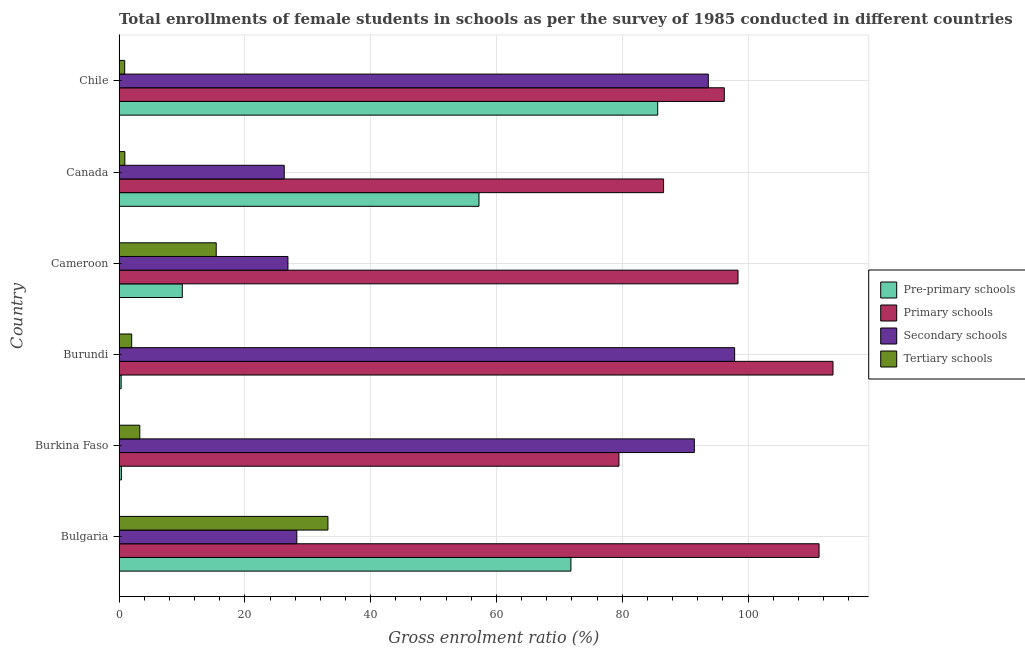Are the number of bars on each tick of the Y-axis equal?
Offer a terse response. Yes. How many bars are there on the 2nd tick from the top?
Keep it short and to the point. 4. How many bars are there on the 2nd tick from the bottom?
Your answer should be compact. 4. What is the label of the 5th group of bars from the top?
Give a very brief answer. Burkina Faso. What is the gross enrolment ratio(female) in secondary schools in Burundi?
Offer a terse response. 97.88. Across all countries, what is the maximum gross enrolment ratio(female) in pre-primary schools?
Give a very brief answer. 85.64. Across all countries, what is the minimum gross enrolment ratio(female) in pre-primary schools?
Ensure brevity in your answer.  0.33. In which country was the gross enrolment ratio(female) in secondary schools maximum?
Give a very brief answer. Burundi. In which country was the gross enrolment ratio(female) in pre-primary schools minimum?
Your answer should be very brief. Burundi. What is the total gross enrolment ratio(female) in tertiary schools in the graph?
Provide a succinct answer. 55.78. What is the difference between the gross enrolment ratio(female) in primary schools in Bulgaria and that in Chile?
Provide a short and direct response. 15.07. What is the difference between the gross enrolment ratio(female) in tertiary schools in Bulgaria and the gross enrolment ratio(female) in secondary schools in Cameroon?
Offer a terse response. 6.36. What is the average gross enrolment ratio(female) in tertiary schools per country?
Give a very brief answer. 9.3. What is the difference between the gross enrolment ratio(female) in secondary schools and gross enrolment ratio(female) in primary schools in Cameroon?
Your response must be concise. -71.56. In how many countries, is the gross enrolment ratio(female) in secondary schools greater than 68 %?
Provide a succinct answer. 3. What is the ratio of the gross enrolment ratio(female) in primary schools in Bulgaria to that in Chile?
Your response must be concise. 1.16. What is the difference between the highest and the second highest gross enrolment ratio(female) in pre-primary schools?
Ensure brevity in your answer.  13.79. What is the difference between the highest and the lowest gross enrolment ratio(female) in pre-primary schools?
Make the answer very short. 85.31. In how many countries, is the gross enrolment ratio(female) in primary schools greater than the average gross enrolment ratio(female) in primary schools taken over all countries?
Your answer should be compact. 3. Is the sum of the gross enrolment ratio(female) in pre-primary schools in Burkina Faso and Canada greater than the maximum gross enrolment ratio(female) in primary schools across all countries?
Provide a succinct answer. No. What does the 4th bar from the top in Cameroon represents?
Give a very brief answer. Pre-primary schools. What does the 3rd bar from the bottom in Cameroon represents?
Offer a very short reply. Secondary schools. Are the values on the major ticks of X-axis written in scientific E-notation?
Provide a short and direct response. No. Does the graph contain any zero values?
Your response must be concise. No. Does the graph contain grids?
Give a very brief answer. Yes. Where does the legend appear in the graph?
Give a very brief answer. Center right. What is the title of the graph?
Your answer should be very brief. Total enrollments of female students in schools as per the survey of 1985 conducted in different countries. What is the label or title of the X-axis?
Ensure brevity in your answer.  Gross enrolment ratio (%). What is the label or title of the Y-axis?
Your response must be concise. Country. What is the Gross enrolment ratio (%) of Pre-primary schools in Bulgaria?
Make the answer very short. 71.84. What is the Gross enrolment ratio (%) in Primary schools in Bulgaria?
Keep it short and to the point. 111.3. What is the Gross enrolment ratio (%) of Secondary schools in Bulgaria?
Provide a succinct answer. 28.26. What is the Gross enrolment ratio (%) in Tertiary schools in Bulgaria?
Offer a terse response. 33.21. What is the Gross enrolment ratio (%) in Pre-primary schools in Burkina Faso?
Provide a succinct answer. 0.38. What is the Gross enrolment ratio (%) in Primary schools in Burkina Faso?
Ensure brevity in your answer.  79.48. What is the Gross enrolment ratio (%) in Secondary schools in Burkina Faso?
Keep it short and to the point. 91.47. What is the Gross enrolment ratio (%) of Tertiary schools in Burkina Faso?
Your answer should be compact. 3.3. What is the Gross enrolment ratio (%) in Pre-primary schools in Burundi?
Give a very brief answer. 0.33. What is the Gross enrolment ratio (%) of Primary schools in Burundi?
Provide a succinct answer. 113.51. What is the Gross enrolment ratio (%) in Secondary schools in Burundi?
Your answer should be very brief. 97.88. What is the Gross enrolment ratio (%) of Tertiary schools in Burundi?
Your answer should be compact. 2.01. What is the Gross enrolment ratio (%) of Pre-primary schools in Cameroon?
Ensure brevity in your answer.  10.06. What is the Gross enrolment ratio (%) in Primary schools in Cameroon?
Offer a terse response. 98.41. What is the Gross enrolment ratio (%) of Secondary schools in Cameroon?
Ensure brevity in your answer.  26.85. What is the Gross enrolment ratio (%) in Tertiary schools in Cameroon?
Offer a very short reply. 15.45. What is the Gross enrolment ratio (%) of Pre-primary schools in Canada?
Make the answer very short. 57.23. What is the Gross enrolment ratio (%) of Primary schools in Canada?
Your answer should be very brief. 86.58. What is the Gross enrolment ratio (%) of Secondary schools in Canada?
Offer a very short reply. 26.26. What is the Gross enrolment ratio (%) of Tertiary schools in Canada?
Give a very brief answer. 0.92. What is the Gross enrolment ratio (%) of Pre-primary schools in Chile?
Your answer should be very brief. 85.64. What is the Gross enrolment ratio (%) in Primary schools in Chile?
Your answer should be compact. 96.23. What is the Gross enrolment ratio (%) of Secondary schools in Chile?
Your answer should be compact. 93.69. What is the Gross enrolment ratio (%) in Tertiary schools in Chile?
Your answer should be very brief. 0.9. Across all countries, what is the maximum Gross enrolment ratio (%) in Pre-primary schools?
Offer a terse response. 85.64. Across all countries, what is the maximum Gross enrolment ratio (%) in Primary schools?
Provide a succinct answer. 113.51. Across all countries, what is the maximum Gross enrolment ratio (%) of Secondary schools?
Keep it short and to the point. 97.88. Across all countries, what is the maximum Gross enrolment ratio (%) of Tertiary schools?
Keep it short and to the point. 33.21. Across all countries, what is the minimum Gross enrolment ratio (%) in Pre-primary schools?
Provide a short and direct response. 0.33. Across all countries, what is the minimum Gross enrolment ratio (%) of Primary schools?
Your answer should be compact. 79.48. Across all countries, what is the minimum Gross enrolment ratio (%) in Secondary schools?
Offer a terse response. 26.26. Across all countries, what is the minimum Gross enrolment ratio (%) of Tertiary schools?
Your response must be concise. 0.9. What is the total Gross enrolment ratio (%) in Pre-primary schools in the graph?
Your response must be concise. 225.48. What is the total Gross enrolment ratio (%) of Primary schools in the graph?
Keep it short and to the point. 585.52. What is the total Gross enrolment ratio (%) in Secondary schools in the graph?
Offer a terse response. 364.42. What is the total Gross enrolment ratio (%) in Tertiary schools in the graph?
Provide a succinct answer. 55.78. What is the difference between the Gross enrolment ratio (%) of Pre-primary schools in Bulgaria and that in Burkina Faso?
Provide a short and direct response. 71.47. What is the difference between the Gross enrolment ratio (%) in Primary schools in Bulgaria and that in Burkina Faso?
Ensure brevity in your answer.  31.82. What is the difference between the Gross enrolment ratio (%) of Secondary schools in Bulgaria and that in Burkina Faso?
Provide a short and direct response. -63.21. What is the difference between the Gross enrolment ratio (%) of Tertiary schools in Bulgaria and that in Burkina Faso?
Provide a succinct answer. 29.91. What is the difference between the Gross enrolment ratio (%) in Pre-primary schools in Bulgaria and that in Burundi?
Your answer should be very brief. 71.51. What is the difference between the Gross enrolment ratio (%) of Primary schools in Bulgaria and that in Burundi?
Your answer should be very brief. -2.22. What is the difference between the Gross enrolment ratio (%) of Secondary schools in Bulgaria and that in Burundi?
Keep it short and to the point. -69.61. What is the difference between the Gross enrolment ratio (%) in Tertiary schools in Bulgaria and that in Burundi?
Ensure brevity in your answer.  31.2. What is the difference between the Gross enrolment ratio (%) in Pre-primary schools in Bulgaria and that in Cameroon?
Make the answer very short. 61.79. What is the difference between the Gross enrolment ratio (%) in Primary schools in Bulgaria and that in Cameroon?
Offer a very short reply. 12.89. What is the difference between the Gross enrolment ratio (%) in Secondary schools in Bulgaria and that in Cameroon?
Make the answer very short. 1.41. What is the difference between the Gross enrolment ratio (%) of Tertiary schools in Bulgaria and that in Cameroon?
Give a very brief answer. 17.76. What is the difference between the Gross enrolment ratio (%) in Pre-primary schools in Bulgaria and that in Canada?
Your response must be concise. 14.62. What is the difference between the Gross enrolment ratio (%) of Primary schools in Bulgaria and that in Canada?
Make the answer very short. 24.72. What is the difference between the Gross enrolment ratio (%) in Secondary schools in Bulgaria and that in Canada?
Offer a terse response. 2. What is the difference between the Gross enrolment ratio (%) of Tertiary schools in Bulgaria and that in Canada?
Provide a succinct answer. 32.29. What is the difference between the Gross enrolment ratio (%) of Pre-primary schools in Bulgaria and that in Chile?
Ensure brevity in your answer.  -13.79. What is the difference between the Gross enrolment ratio (%) in Primary schools in Bulgaria and that in Chile?
Provide a succinct answer. 15.07. What is the difference between the Gross enrolment ratio (%) in Secondary schools in Bulgaria and that in Chile?
Offer a terse response. -65.43. What is the difference between the Gross enrolment ratio (%) of Tertiary schools in Bulgaria and that in Chile?
Your answer should be very brief. 32.31. What is the difference between the Gross enrolment ratio (%) of Pre-primary schools in Burkina Faso and that in Burundi?
Your answer should be very brief. 0.04. What is the difference between the Gross enrolment ratio (%) in Primary schools in Burkina Faso and that in Burundi?
Keep it short and to the point. -34.03. What is the difference between the Gross enrolment ratio (%) of Secondary schools in Burkina Faso and that in Burundi?
Keep it short and to the point. -6.41. What is the difference between the Gross enrolment ratio (%) of Tertiary schools in Burkina Faso and that in Burundi?
Ensure brevity in your answer.  1.29. What is the difference between the Gross enrolment ratio (%) of Pre-primary schools in Burkina Faso and that in Cameroon?
Offer a terse response. -9.68. What is the difference between the Gross enrolment ratio (%) of Primary schools in Burkina Faso and that in Cameroon?
Make the answer very short. -18.93. What is the difference between the Gross enrolment ratio (%) of Secondary schools in Burkina Faso and that in Cameroon?
Provide a short and direct response. 64.62. What is the difference between the Gross enrolment ratio (%) in Tertiary schools in Burkina Faso and that in Cameroon?
Keep it short and to the point. -12.15. What is the difference between the Gross enrolment ratio (%) in Pre-primary schools in Burkina Faso and that in Canada?
Make the answer very short. -56.85. What is the difference between the Gross enrolment ratio (%) in Primary schools in Burkina Faso and that in Canada?
Provide a succinct answer. -7.09. What is the difference between the Gross enrolment ratio (%) in Secondary schools in Burkina Faso and that in Canada?
Your answer should be compact. 65.21. What is the difference between the Gross enrolment ratio (%) in Tertiary schools in Burkina Faso and that in Canada?
Keep it short and to the point. 2.38. What is the difference between the Gross enrolment ratio (%) of Pre-primary schools in Burkina Faso and that in Chile?
Keep it short and to the point. -85.26. What is the difference between the Gross enrolment ratio (%) of Primary schools in Burkina Faso and that in Chile?
Your answer should be very brief. -16.75. What is the difference between the Gross enrolment ratio (%) of Secondary schools in Burkina Faso and that in Chile?
Your answer should be very brief. -2.22. What is the difference between the Gross enrolment ratio (%) of Tertiary schools in Burkina Faso and that in Chile?
Your answer should be compact. 2.4. What is the difference between the Gross enrolment ratio (%) in Pre-primary schools in Burundi and that in Cameroon?
Provide a succinct answer. -9.73. What is the difference between the Gross enrolment ratio (%) of Primary schools in Burundi and that in Cameroon?
Make the answer very short. 15.1. What is the difference between the Gross enrolment ratio (%) in Secondary schools in Burundi and that in Cameroon?
Provide a short and direct response. 71.02. What is the difference between the Gross enrolment ratio (%) in Tertiary schools in Burundi and that in Cameroon?
Offer a terse response. -13.44. What is the difference between the Gross enrolment ratio (%) of Pre-primary schools in Burundi and that in Canada?
Offer a very short reply. -56.9. What is the difference between the Gross enrolment ratio (%) of Primary schools in Burundi and that in Canada?
Your answer should be compact. 26.94. What is the difference between the Gross enrolment ratio (%) in Secondary schools in Burundi and that in Canada?
Ensure brevity in your answer.  71.61. What is the difference between the Gross enrolment ratio (%) in Tertiary schools in Burundi and that in Canada?
Offer a very short reply. 1.09. What is the difference between the Gross enrolment ratio (%) of Pre-primary schools in Burundi and that in Chile?
Your response must be concise. -85.31. What is the difference between the Gross enrolment ratio (%) in Primary schools in Burundi and that in Chile?
Provide a succinct answer. 17.28. What is the difference between the Gross enrolment ratio (%) in Secondary schools in Burundi and that in Chile?
Keep it short and to the point. 4.19. What is the difference between the Gross enrolment ratio (%) of Tertiary schools in Burundi and that in Chile?
Your answer should be very brief. 1.11. What is the difference between the Gross enrolment ratio (%) of Pre-primary schools in Cameroon and that in Canada?
Your answer should be very brief. -47.17. What is the difference between the Gross enrolment ratio (%) in Primary schools in Cameroon and that in Canada?
Make the answer very short. 11.84. What is the difference between the Gross enrolment ratio (%) in Secondary schools in Cameroon and that in Canada?
Offer a terse response. 0.59. What is the difference between the Gross enrolment ratio (%) of Tertiary schools in Cameroon and that in Canada?
Give a very brief answer. 14.53. What is the difference between the Gross enrolment ratio (%) in Pre-primary schools in Cameroon and that in Chile?
Offer a very short reply. -75.58. What is the difference between the Gross enrolment ratio (%) of Primary schools in Cameroon and that in Chile?
Your answer should be compact. 2.18. What is the difference between the Gross enrolment ratio (%) of Secondary schools in Cameroon and that in Chile?
Provide a succinct answer. -66.84. What is the difference between the Gross enrolment ratio (%) of Tertiary schools in Cameroon and that in Chile?
Ensure brevity in your answer.  14.55. What is the difference between the Gross enrolment ratio (%) in Pre-primary schools in Canada and that in Chile?
Offer a very short reply. -28.41. What is the difference between the Gross enrolment ratio (%) of Primary schools in Canada and that in Chile?
Offer a very short reply. -9.65. What is the difference between the Gross enrolment ratio (%) in Secondary schools in Canada and that in Chile?
Offer a terse response. -67.43. What is the difference between the Gross enrolment ratio (%) in Tertiary schools in Canada and that in Chile?
Provide a succinct answer. 0.02. What is the difference between the Gross enrolment ratio (%) in Pre-primary schools in Bulgaria and the Gross enrolment ratio (%) in Primary schools in Burkina Faso?
Give a very brief answer. -7.64. What is the difference between the Gross enrolment ratio (%) of Pre-primary schools in Bulgaria and the Gross enrolment ratio (%) of Secondary schools in Burkina Faso?
Make the answer very short. -19.62. What is the difference between the Gross enrolment ratio (%) of Pre-primary schools in Bulgaria and the Gross enrolment ratio (%) of Tertiary schools in Burkina Faso?
Offer a terse response. 68.55. What is the difference between the Gross enrolment ratio (%) in Primary schools in Bulgaria and the Gross enrolment ratio (%) in Secondary schools in Burkina Faso?
Provide a short and direct response. 19.83. What is the difference between the Gross enrolment ratio (%) of Primary schools in Bulgaria and the Gross enrolment ratio (%) of Tertiary schools in Burkina Faso?
Your answer should be compact. 108. What is the difference between the Gross enrolment ratio (%) of Secondary schools in Bulgaria and the Gross enrolment ratio (%) of Tertiary schools in Burkina Faso?
Provide a succinct answer. 24.97. What is the difference between the Gross enrolment ratio (%) of Pre-primary schools in Bulgaria and the Gross enrolment ratio (%) of Primary schools in Burundi?
Keep it short and to the point. -41.67. What is the difference between the Gross enrolment ratio (%) in Pre-primary schools in Bulgaria and the Gross enrolment ratio (%) in Secondary schools in Burundi?
Make the answer very short. -26.03. What is the difference between the Gross enrolment ratio (%) of Pre-primary schools in Bulgaria and the Gross enrolment ratio (%) of Tertiary schools in Burundi?
Ensure brevity in your answer.  69.83. What is the difference between the Gross enrolment ratio (%) in Primary schools in Bulgaria and the Gross enrolment ratio (%) in Secondary schools in Burundi?
Provide a short and direct response. 13.42. What is the difference between the Gross enrolment ratio (%) of Primary schools in Bulgaria and the Gross enrolment ratio (%) of Tertiary schools in Burundi?
Give a very brief answer. 109.29. What is the difference between the Gross enrolment ratio (%) of Secondary schools in Bulgaria and the Gross enrolment ratio (%) of Tertiary schools in Burundi?
Keep it short and to the point. 26.25. What is the difference between the Gross enrolment ratio (%) of Pre-primary schools in Bulgaria and the Gross enrolment ratio (%) of Primary schools in Cameroon?
Provide a short and direct response. -26.57. What is the difference between the Gross enrolment ratio (%) in Pre-primary schools in Bulgaria and the Gross enrolment ratio (%) in Secondary schools in Cameroon?
Give a very brief answer. 44.99. What is the difference between the Gross enrolment ratio (%) in Pre-primary schools in Bulgaria and the Gross enrolment ratio (%) in Tertiary schools in Cameroon?
Your answer should be compact. 56.4. What is the difference between the Gross enrolment ratio (%) in Primary schools in Bulgaria and the Gross enrolment ratio (%) in Secondary schools in Cameroon?
Offer a terse response. 84.45. What is the difference between the Gross enrolment ratio (%) of Primary schools in Bulgaria and the Gross enrolment ratio (%) of Tertiary schools in Cameroon?
Your response must be concise. 95.85. What is the difference between the Gross enrolment ratio (%) of Secondary schools in Bulgaria and the Gross enrolment ratio (%) of Tertiary schools in Cameroon?
Provide a short and direct response. 12.82. What is the difference between the Gross enrolment ratio (%) of Pre-primary schools in Bulgaria and the Gross enrolment ratio (%) of Primary schools in Canada?
Keep it short and to the point. -14.73. What is the difference between the Gross enrolment ratio (%) in Pre-primary schools in Bulgaria and the Gross enrolment ratio (%) in Secondary schools in Canada?
Your answer should be compact. 45.58. What is the difference between the Gross enrolment ratio (%) of Pre-primary schools in Bulgaria and the Gross enrolment ratio (%) of Tertiary schools in Canada?
Your response must be concise. 70.92. What is the difference between the Gross enrolment ratio (%) in Primary schools in Bulgaria and the Gross enrolment ratio (%) in Secondary schools in Canada?
Your answer should be compact. 85.03. What is the difference between the Gross enrolment ratio (%) of Primary schools in Bulgaria and the Gross enrolment ratio (%) of Tertiary schools in Canada?
Give a very brief answer. 110.38. What is the difference between the Gross enrolment ratio (%) in Secondary schools in Bulgaria and the Gross enrolment ratio (%) in Tertiary schools in Canada?
Make the answer very short. 27.34. What is the difference between the Gross enrolment ratio (%) of Pre-primary schools in Bulgaria and the Gross enrolment ratio (%) of Primary schools in Chile?
Provide a succinct answer. -24.39. What is the difference between the Gross enrolment ratio (%) of Pre-primary schools in Bulgaria and the Gross enrolment ratio (%) of Secondary schools in Chile?
Give a very brief answer. -21.85. What is the difference between the Gross enrolment ratio (%) in Pre-primary schools in Bulgaria and the Gross enrolment ratio (%) in Tertiary schools in Chile?
Provide a short and direct response. 70.95. What is the difference between the Gross enrolment ratio (%) of Primary schools in Bulgaria and the Gross enrolment ratio (%) of Secondary schools in Chile?
Provide a succinct answer. 17.61. What is the difference between the Gross enrolment ratio (%) of Primary schools in Bulgaria and the Gross enrolment ratio (%) of Tertiary schools in Chile?
Your response must be concise. 110.4. What is the difference between the Gross enrolment ratio (%) in Secondary schools in Bulgaria and the Gross enrolment ratio (%) in Tertiary schools in Chile?
Ensure brevity in your answer.  27.37. What is the difference between the Gross enrolment ratio (%) of Pre-primary schools in Burkina Faso and the Gross enrolment ratio (%) of Primary schools in Burundi?
Keep it short and to the point. -113.14. What is the difference between the Gross enrolment ratio (%) of Pre-primary schools in Burkina Faso and the Gross enrolment ratio (%) of Secondary schools in Burundi?
Provide a short and direct response. -97.5. What is the difference between the Gross enrolment ratio (%) in Pre-primary schools in Burkina Faso and the Gross enrolment ratio (%) in Tertiary schools in Burundi?
Ensure brevity in your answer.  -1.63. What is the difference between the Gross enrolment ratio (%) in Primary schools in Burkina Faso and the Gross enrolment ratio (%) in Secondary schools in Burundi?
Provide a short and direct response. -18.39. What is the difference between the Gross enrolment ratio (%) of Primary schools in Burkina Faso and the Gross enrolment ratio (%) of Tertiary schools in Burundi?
Provide a succinct answer. 77.47. What is the difference between the Gross enrolment ratio (%) of Secondary schools in Burkina Faso and the Gross enrolment ratio (%) of Tertiary schools in Burundi?
Provide a short and direct response. 89.46. What is the difference between the Gross enrolment ratio (%) in Pre-primary schools in Burkina Faso and the Gross enrolment ratio (%) in Primary schools in Cameroon?
Provide a short and direct response. -98.04. What is the difference between the Gross enrolment ratio (%) in Pre-primary schools in Burkina Faso and the Gross enrolment ratio (%) in Secondary schools in Cameroon?
Give a very brief answer. -26.48. What is the difference between the Gross enrolment ratio (%) of Pre-primary schools in Burkina Faso and the Gross enrolment ratio (%) of Tertiary schools in Cameroon?
Provide a short and direct response. -15.07. What is the difference between the Gross enrolment ratio (%) of Primary schools in Burkina Faso and the Gross enrolment ratio (%) of Secondary schools in Cameroon?
Give a very brief answer. 52.63. What is the difference between the Gross enrolment ratio (%) of Primary schools in Burkina Faso and the Gross enrolment ratio (%) of Tertiary schools in Cameroon?
Make the answer very short. 64.04. What is the difference between the Gross enrolment ratio (%) of Secondary schools in Burkina Faso and the Gross enrolment ratio (%) of Tertiary schools in Cameroon?
Your answer should be very brief. 76.02. What is the difference between the Gross enrolment ratio (%) in Pre-primary schools in Burkina Faso and the Gross enrolment ratio (%) in Primary schools in Canada?
Your answer should be compact. -86.2. What is the difference between the Gross enrolment ratio (%) in Pre-primary schools in Burkina Faso and the Gross enrolment ratio (%) in Secondary schools in Canada?
Provide a succinct answer. -25.89. What is the difference between the Gross enrolment ratio (%) in Pre-primary schools in Burkina Faso and the Gross enrolment ratio (%) in Tertiary schools in Canada?
Your answer should be very brief. -0.54. What is the difference between the Gross enrolment ratio (%) of Primary schools in Burkina Faso and the Gross enrolment ratio (%) of Secondary schools in Canada?
Provide a short and direct response. 53.22. What is the difference between the Gross enrolment ratio (%) in Primary schools in Burkina Faso and the Gross enrolment ratio (%) in Tertiary schools in Canada?
Offer a terse response. 78.56. What is the difference between the Gross enrolment ratio (%) of Secondary schools in Burkina Faso and the Gross enrolment ratio (%) of Tertiary schools in Canada?
Your response must be concise. 90.55. What is the difference between the Gross enrolment ratio (%) in Pre-primary schools in Burkina Faso and the Gross enrolment ratio (%) in Primary schools in Chile?
Offer a very short reply. -95.85. What is the difference between the Gross enrolment ratio (%) of Pre-primary schools in Burkina Faso and the Gross enrolment ratio (%) of Secondary schools in Chile?
Your answer should be compact. -93.31. What is the difference between the Gross enrolment ratio (%) of Pre-primary schools in Burkina Faso and the Gross enrolment ratio (%) of Tertiary schools in Chile?
Your answer should be compact. -0.52. What is the difference between the Gross enrolment ratio (%) of Primary schools in Burkina Faso and the Gross enrolment ratio (%) of Secondary schools in Chile?
Your answer should be very brief. -14.21. What is the difference between the Gross enrolment ratio (%) of Primary schools in Burkina Faso and the Gross enrolment ratio (%) of Tertiary schools in Chile?
Make the answer very short. 78.59. What is the difference between the Gross enrolment ratio (%) of Secondary schools in Burkina Faso and the Gross enrolment ratio (%) of Tertiary schools in Chile?
Provide a succinct answer. 90.57. What is the difference between the Gross enrolment ratio (%) in Pre-primary schools in Burundi and the Gross enrolment ratio (%) in Primary schools in Cameroon?
Offer a very short reply. -98.08. What is the difference between the Gross enrolment ratio (%) of Pre-primary schools in Burundi and the Gross enrolment ratio (%) of Secondary schools in Cameroon?
Ensure brevity in your answer.  -26.52. What is the difference between the Gross enrolment ratio (%) in Pre-primary schools in Burundi and the Gross enrolment ratio (%) in Tertiary schools in Cameroon?
Offer a very short reply. -15.12. What is the difference between the Gross enrolment ratio (%) in Primary schools in Burundi and the Gross enrolment ratio (%) in Secondary schools in Cameroon?
Provide a succinct answer. 86.66. What is the difference between the Gross enrolment ratio (%) of Primary schools in Burundi and the Gross enrolment ratio (%) of Tertiary schools in Cameroon?
Give a very brief answer. 98.07. What is the difference between the Gross enrolment ratio (%) in Secondary schools in Burundi and the Gross enrolment ratio (%) in Tertiary schools in Cameroon?
Offer a very short reply. 82.43. What is the difference between the Gross enrolment ratio (%) in Pre-primary schools in Burundi and the Gross enrolment ratio (%) in Primary schools in Canada?
Provide a succinct answer. -86.25. What is the difference between the Gross enrolment ratio (%) in Pre-primary schools in Burundi and the Gross enrolment ratio (%) in Secondary schools in Canada?
Give a very brief answer. -25.93. What is the difference between the Gross enrolment ratio (%) of Pre-primary schools in Burundi and the Gross enrolment ratio (%) of Tertiary schools in Canada?
Your answer should be very brief. -0.59. What is the difference between the Gross enrolment ratio (%) of Primary schools in Burundi and the Gross enrolment ratio (%) of Secondary schools in Canada?
Your response must be concise. 87.25. What is the difference between the Gross enrolment ratio (%) in Primary schools in Burundi and the Gross enrolment ratio (%) in Tertiary schools in Canada?
Your response must be concise. 112.59. What is the difference between the Gross enrolment ratio (%) in Secondary schools in Burundi and the Gross enrolment ratio (%) in Tertiary schools in Canada?
Your answer should be very brief. 96.96. What is the difference between the Gross enrolment ratio (%) of Pre-primary schools in Burundi and the Gross enrolment ratio (%) of Primary schools in Chile?
Keep it short and to the point. -95.9. What is the difference between the Gross enrolment ratio (%) in Pre-primary schools in Burundi and the Gross enrolment ratio (%) in Secondary schools in Chile?
Offer a terse response. -93.36. What is the difference between the Gross enrolment ratio (%) of Pre-primary schools in Burundi and the Gross enrolment ratio (%) of Tertiary schools in Chile?
Your response must be concise. -0.57. What is the difference between the Gross enrolment ratio (%) in Primary schools in Burundi and the Gross enrolment ratio (%) in Secondary schools in Chile?
Your response must be concise. 19.82. What is the difference between the Gross enrolment ratio (%) in Primary schools in Burundi and the Gross enrolment ratio (%) in Tertiary schools in Chile?
Offer a terse response. 112.62. What is the difference between the Gross enrolment ratio (%) of Secondary schools in Burundi and the Gross enrolment ratio (%) of Tertiary schools in Chile?
Make the answer very short. 96.98. What is the difference between the Gross enrolment ratio (%) of Pre-primary schools in Cameroon and the Gross enrolment ratio (%) of Primary schools in Canada?
Your answer should be compact. -76.52. What is the difference between the Gross enrolment ratio (%) of Pre-primary schools in Cameroon and the Gross enrolment ratio (%) of Secondary schools in Canada?
Provide a short and direct response. -16.21. What is the difference between the Gross enrolment ratio (%) of Pre-primary schools in Cameroon and the Gross enrolment ratio (%) of Tertiary schools in Canada?
Your response must be concise. 9.14. What is the difference between the Gross enrolment ratio (%) in Primary schools in Cameroon and the Gross enrolment ratio (%) in Secondary schools in Canada?
Ensure brevity in your answer.  72.15. What is the difference between the Gross enrolment ratio (%) in Primary schools in Cameroon and the Gross enrolment ratio (%) in Tertiary schools in Canada?
Offer a very short reply. 97.49. What is the difference between the Gross enrolment ratio (%) in Secondary schools in Cameroon and the Gross enrolment ratio (%) in Tertiary schools in Canada?
Provide a succinct answer. 25.93. What is the difference between the Gross enrolment ratio (%) in Pre-primary schools in Cameroon and the Gross enrolment ratio (%) in Primary schools in Chile?
Give a very brief answer. -86.17. What is the difference between the Gross enrolment ratio (%) in Pre-primary schools in Cameroon and the Gross enrolment ratio (%) in Secondary schools in Chile?
Ensure brevity in your answer.  -83.63. What is the difference between the Gross enrolment ratio (%) in Pre-primary schools in Cameroon and the Gross enrolment ratio (%) in Tertiary schools in Chile?
Ensure brevity in your answer.  9.16. What is the difference between the Gross enrolment ratio (%) in Primary schools in Cameroon and the Gross enrolment ratio (%) in Secondary schools in Chile?
Give a very brief answer. 4.72. What is the difference between the Gross enrolment ratio (%) in Primary schools in Cameroon and the Gross enrolment ratio (%) in Tertiary schools in Chile?
Give a very brief answer. 97.52. What is the difference between the Gross enrolment ratio (%) in Secondary schools in Cameroon and the Gross enrolment ratio (%) in Tertiary schools in Chile?
Offer a very short reply. 25.96. What is the difference between the Gross enrolment ratio (%) of Pre-primary schools in Canada and the Gross enrolment ratio (%) of Primary schools in Chile?
Offer a terse response. -39. What is the difference between the Gross enrolment ratio (%) in Pre-primary schools in Canada and the Gross enrolment ratio (%) in Secondary schools in Chile?
Give a very brief answer. -36.46. What is the difference between the Gross enrolment ratio (%) in Pre-primary schools in Canada and the Gross enrolment ratio (%) in Tertiary schools in Chile?
Offer a terse response. 56.33. What is the difference between the Gross enrolment ratio (%) in Primary schools in Canada and the Gross enrolment ratio (%) in Secondary schools in Chile?
Offer a very short reply. -7.11. What is the difference between the Gross enrolment ratio (%) in Primary schools in Canada and the Gross enrolment ratio (%) in Tertiary schools in Chile?
Keep it short and to the point. 85.68. What is the difference between the Gross enrolment ratio (%) of Secondary schools in Canada and the Gross enrolment ratio (%) of Tertiary schools in Chile?
Provide a succinct answer. 25.37. What is the average Gross enrolment ratio (%) of Pre-primary schools per country?
Ensure brevity in your answer.  37.58. What is the average Gross enrolment ratio (%) of Primary schools per country?
Provide a short and direct response. 97.59. What is the average Gross enrolment ratio (%) of Secondary schools per country?
Make the answer very short. 60.74. What is the average Gross enrolment ratio (%) of Tertiary schools per country?
Your response must be concise. 9.3. What is the difference between the Gross enrolment ratio (%) of Pre-primary schools and Gross enrolment ratio (%) of Primary schools in Bulgaria?
Offer a terse response. -39.45. What is the difference between the Gross enrolment ratio (%) in Pre-primary schools and Gross enrolment ratio (%) in Secondary schools in Bulgaria?
Make the answer very short. 43.58. What is the difference between the Gross enrolment ratio (%) of Pre-primary schools and Gross enrolment ratio (%) of Tertiary schools in Bulgaria?
Provide a succinct answer. 38.63. What is the difference between the Gross enrolment ratio (%) of Primary schools and Gross enrolment ratio (%) of Secondary schools in Bulgaria?
Give a very brief answer. 83.03. What is the difference between the Gross enrolment ratio (%) in Primary schools and Gross enrolment ratio (%) in Tertiary schools in Bulgaria?
Your response must be concise. 78.09. What is the difference between the Gross enrolment ratio (%) of Secondary schools and Gross enrolment ratio (%) of Tertiary schools in Bulgaria?
Offer a terse response. -4.95. What is the difference between the Gross enrolment ratio (%) of Pre-primary schools and Gross enrolment ratio (%) of Primary schools in Burkina Faso?
Provide a succinct answer. -79.11. What is the difference between the Gross enrolment ratio (%) of Pre-primary schools and Gross enrolment ratio (%) of Secondary schools in Burkina Faso?
Provide a short and direct response. -91.09. What is the difference between the Gross enrolment ratio (%) of Pre-primary schools and Gross enrolment ratio (%) of Tertiary schools in Burkina Faso?
Provide a short and direct response. -2.92. What is the difference between the Gross enrolment ratio (%) in Primary schools and Gross enrolment ratio (%) in Secondary schools in Burkina Faso?
Offer a very short reply. -11.99. What is the difference between the Gross enrolment ratio (%) in Primary schools and Gross enrolment ratio (%) in Tertiary schools in Burkina Faso?
Provide a succinct answer. 76.19. What is the difference between the Gross enrolment ratio (%) in Secondary schools and Gross enrolment ratio (%) in Tertiary schools in Burkina Faso?
Offer a very short reply. 88.17. What is the difference between the Gross enrolment ratio (%) of Pre-primary schools and Gross enrolment ratio (%) of Primary schools in Burundi?
Offer a terse response. -113.18. What is the difference between the Gross enrolment ratio (%) of Pre-primary schools and Gross enrolment ratio (%) of Secondary schools in Burundi?
Make the answer very short. -97.54. What is the difference between the Gross enrolment ratio (%) in Pre-primary schools and Gross enrolment ratio (%) in Tertiary schools in Burundi?
Keep it short and to the point. -1.68. What is the difference between the Gross enrolment ratio (%) in Primary schools and Gross enrolment ratio (%) in Secondary schools in Burundi?
Provide a short and direct response. 15.64. What is the difference between the Gross enrolment ratio (%) of Primary schools and Gross enrolment ratio (%) of Tertiary schools in Burundi?
Provide a short and direct response. 111.5. What is the difference between the Gross enrolment ratio (%) of Secondary schools and Gross enrolment ratio (%) of Tertiary schools in Burundi?
Your response must be concise. 95.87. What is the difference between the Gross enrolment ratio (%) in Pre-primary schools and Gross enrolment ratio (%) in Primary schools in Cameroon?
Ensure brevity in your answer.  -88.36. What is the difference between the Gross enrolment ratio (%) of Pre-primary schools and Gross enrolment ratio (%) of Secondary schools in Cameroon?
Ensure brevity in your answer.  -16.8. What is the difference between the Gross enrolment ratio (%) in Pre-primary schools and Gross enrolment ratio (%) in Tertiary schools in Cameroon?
Give a very brief answer. -5.39. What is the difference between the Gross enrolment ratio (%) of Primary schools and Gross enrolment ratio (%) of Secondary schools in Cameroon?
Your answer should be very brief. 71.56. What is the difference between the Gross enrolment ratio (%) of Primary schools and Gross enrolment ratio (%) of Tertiary schools in Cameroon?
Make the answer very short. 82.97. What is the difference between the Gross enrolment ratio (%) of Secondary schools and Gross enrolment ratio (%) of Tertiary schools in Cameroon?
Your answer should be compact. 11.41. What is the difference between the Gross enrolment ratio (%) of Pre-primary schools and Gross enrolment ratio (%) of Primary schools in Canada?
Ensure brevity in your answer.  -29.35. What is the difference between the Gross enrolment ratio (%) of Pre-primary schools and Gross enrolment ratio (%) of Secondary schools in Canada?
Give a very brief answer. 30.96. What is the difference between the Gross enrolment ratio (%) of Pre-primary schools and Gross enrolment ratio (%) of Tertiary schools in Canada?
Ensure brevity in your answer.  56.31. What is the difference between the Gross enrolment ratio (%) in Primary schools and Gross enrolment ratio (%) in Secondary schools in Canada?
Make the answer very short. 60.31. What is the difference between the Gross enrolment ratio (%) of Primary schools and Gross enrolment ratio (%) of Tertiary schools in Canada?
Offer a very short reply. 85.66. What is the difference between the Gross enrolment ratio (%) in Secondary schools and Gross enrolment ratio (%) in Tertiary schools in Canada?
Make the answer very short. 25.34. What is the difference between the Gross enrolment ratio (%) of Pre-primary schools and Gross enrolment ratio (%) of Primary schools in Chile?
Your answer should be compact. -10.59. What is the difference between the Gross enrolment ratio (%) in Pre-primary schools and Gross enrolment ratio (%) in Secondary schools in Chile?
Offer a very short reply. -8.05. What is the difference between the Gross enrolment ratio (%) in Pre-primary schools and Gross enrolment ratio (%) in Tertiary schools in Chile?
Your answer should be compact. 84.74. What is the difference between the Gross enrolment ratio (%) in Primary schools and Gross enrolment ratio (%) in Secondary schools in Chile?
Offer a terse response. 2.54. What is the difference between the Gross enrolment ratio (%) of Primary schools and Gross enrolment ratio (%) of Tertiary schools in Chile?
Provide a succinct answer. 95.33. What is the difference between the Gross enrolment ratio (%) in Secondary schools and Gross enrolment ratio (%) in Tertiary schools in Chile?
Offer a very short reply. 92.79. What is the ratio of the Gross enrolment ratio (%) in Pre-primary schools in Bulgaria to that in Burkina Faso?
Ensure brevity in your answer.  191.33. What is the ratio of the Gross enrolment ratio (%) in Primary schools in Bulgaria to that in Burkina Faso?
Offer a very short reply. 1.4. What is the ratio of the Gross enrolment ratio (%) of Secondary schools in Bulgaria to that in Burkina Faso?
Offer a terse response. 0.31. What is the ratio of the Gross enrolment ratio (%) of Tertiary schools in Bulgaria to that in Burkina Faso?
Provide a short and direct response. 10.07. What is the ratio of the Gross enrolment ratio (%) of Pre-primary schools in Bulgaria to that in Burundi?
Ensure brevity in your answer.  216.61. What is the ratio of the Gross enrolment ratio (%) of Primary schools in Bulgaria to that in Burundi?
Ensure brevity in your answer.  0.98. What is the ratio of the Gross enrolment ratio (%) of Secondary schools in Bulgaria to that in Burundi?
Offer a terse response. 0.29. What is the ratio of the Gross enrolment ratio (%) of Tertiary schools in Bulgaria to that in Burundi?
Provide a succinct answer. 16.52. What is the ratio of the Gross enrolment ratio (%) in Pre-primary schools in Bulgaria to that in Cameroon?
Keep it short and to the point. 7.14. What is the ratio of the Gross enrolment ratio (%) in Primary schools in Bulgaria to that in Cameroon?
Offer a terse response. 1.13. What is the ratio of the Gross enrolment ratio (%) of Secondary schools in Bulgaria to that in Cameroon?
Make the answer very short. 1.05. What is the ratio of the Gross enrolment ratio (%) in Tertiary schools in Bulgaria to that in Cameroon?
Offer a terse response. 2.15. What is the ratio of the Gross enrolment ratio (%) in Pre-primary schools in Bulgaria to that in Canada?
Provide a succinct answer. 1.26. What is the ratio of the Gross enrolment ratio (%) in Primary schools in Bulgaria to that in Canada?
Your answer should be very brief. 1.29. What is the ratio of the Gross enrolment ratio (%) of Secondary schools in Bulgaria to that in Canada?
Keep it short and to the point. 1.08. What is the ratio of the Gross enrolment ratio (%) in Tertiary schools in Bulgaria to that in Canada?
Your response must be concise. 36.11. What is the ratio of the Gross enrolment ratio (%) in Pre-primary schools in Bulgaria to that in Chile?
Give a very brief answer. 0.84. What is the ratio of the Gross enrolment ratio (%) of Primary schools in Bulgaria to that in Chile?
Keep it short and to the point. 1.16. What is the ratio of the Gross enrolment ratio (%) of Secondary schools in Bulgaria to that in Chile?
Your answer should be very brief. 0.3. What is the ratio of the Gross enrolment ratio (%) of Tertiary schools in Bulgaria to that in Chile?
Provide a succinct answer. 36.99. What is the ratio of the Gross enrolment ratio (%) in Pre-primary schools in Burkina Faso to that in Burundi?
Keep it short and to the point. 1.13. What is the ratio of the Gross enrolment ratio (%) in Primary schools in Burkina Faso to that in Burundi?
Keep it short and to the point. 0.7. What is the ratio of the Gross enrolment ratio (%) of Secondary schools in Burkina Faso to that in Burundi?
Offer a terse response. 0.93. What is the ratio of the Gross enrolment ratio (%) in Tertiary schools in Burkina Faso to that in Burundi?
Give a very brief answer. 1.64. What is the ratio of the Gross enrolment ratio (%) of Pre-primary schools in Burkina Faso to that in Cameroon?
Offer a terse response. 0.04. What is the ratio of the Gross enrolment ratio (%) in Primary schools in Burkina Faso to that in Cameroon?
Keep it short and to the point. 0.81. What is the ratio of the Gross enrolment ratio (%) in Secondary schools in Burkina Faso to that in Cameroon?
Keep it short and to the point. 3.41. What is the ratio of the Gross enrolment ratio (%) of Tertiary schools in Burkina Faso to that in Cameroon?
Offer a very short reply. 0.21. What is the ratio of the Gross enrolment ratio (%) in Pre-primary schools in Burkina Faso to that in Canada?
Give a very brief answer. 0.01. What is the ratio of the Gross enrolment ratio (%) in Primary schools in Burkina Faso to that in Canada?
Keep it short and to the point. 0.92. What is the ratio of the Gross enrolment ratio (%) in Secondary schools in Burkina Faso to that in Canada?
Your response must be concise. 3.48. What is the ratio of the Gross enrolment ratio (%) in Tertiary schools in Burkina Faso to that in Canada?
Provide a succinct answer. 3.59. What is the ratio of the Gross enrolment ratio (%) of Pre-primary schools in Burkina Faso to that in Chile?
Your answer should be very brief. 0. What is the ratio of the Gross enrolment ratio (%) of Primary schools in Burkina Faso to that in Chile?
Provide a short and direct response. 0.83. What is the ratio of the Gross enrolment ratio (%) in Secondary schools in Burkina Faso to that in Chile?
Offer a very short reply. 0.98. What is the ratio of the Gross enrolment ratio (%) of Tertiary schools in Burkina Faso to that in Chile?
Provide a short and direct response. 3.67. What is the ratio of the Gross enrolment ratio (%) of Pre-primary schools in Burundi to that in Cameroon?
Give a very brief answer. 0.03. What is the ratio of the Gross enrolment ratio (%) in Primary schools in Burundi to that in Cameroon?
Offer a terse response. 1.15. What is the ratio of the Gross enrolment ratio (%) of Secondary schools in Burundi to that in Cameroon?
Your response must be concise. 3.64. What is the ratio of the Gross enrolment ratio (%) of Tertiary schools in Burundi to that in Cameroon?
Give a very brief answer. 0.13. What is the ratio of the Gross enrolment ratio (%) of Pre-primary schools in Burundi to that in Canada?
Keep it short and to the point. 0.01. What is the ratio of the Gross enrolment ratio (%) in Primary schools in Burundi to that in Canada?
Offer a terse response. 1.31. What is the ratio of the Gross enrolment ratio (%) of Secondary schools in Burundi to that in Canada?
Your answer should be very brief. 3.73. What is the ratio of the Gross enrolment ratio (%) in Tertiary schools in Burundi to that in Canada?
Offer a very short reply. 2.19. What is the ratio of the Gross enrolment ratio (%) of Pre-primary schools in Burundi to that in Chile?
Keep it short and to the point. 0. What is the ratio of the Gross enrolment ratio (%) in Primary schools in Burundi to that in Chile?
Keep it short and to the point. 1.18. What is the ratio of the Gross enrolment ratio (%) in Secondary schools in Burundi to that in Chile?
Keep it short and to the point. 1.04. What is the ratio of the Gross enrolment ratio (%) in Tertiary schools in Burundi to that in Chile?
Provide a short and direct response. 2.24. What is the ratio of the Gross enrolment ratio (%) in Pre-primary schools in Cameroon to that in Canada?
Offer a very short reply. 0.18. What is the ratio of the Gross enrolment ratio (%) in Primary schools in Cameroon to that in Canada?
Provide a short and direct response. 1.14. What is the ratio of the Gross enrolment ratio (%) of Secondary schools in Cameroon to that in Canada?
Your response must be concise. 1.02. What is the ratio of the Gross enrolment ratio (%) of Tertiary schools in Cameroon to that in Canada?
Ensure brevity in your answer.  16.8. What is the ratio of the Gross enrolment ratio (%) in Pre-primary schools in Cameroon to that in Chile?
Offer a terse response. 0.12. What is the ratio of the Gross enrolment ratio (%) of Primary schools in Cameroon to that in Chile?
Your answer should be very brief. 1.02. What is the ratio of the Gross enrolment ratio (%) of Secondary schools in Cameroon to that in Chile?
Provide a succinct answer. 0.29. What is the ratio of the Gross enrolment ratio (%) of Tertiary schools in Cameroon to that in Chile?
Keep it short and to the point. 17.2. What is the ratio of the Gross enrolment ratio (%) of Pre-primary schools in Canada to that in Chile?
Keep it short and to the point. 0.67. What is the ratio of the Gross enrolment ratio (%) of Primary schools in Canada to that in Chile?
Offer a terse response. 0.9. What is the ratio of the Gross enrolment ratio (%) in Secondary schools in Canada to that in Chile?
Offer a terse response. 0.28. What is the ratio of the Gross enrolment ratio (%) in Tertiary schools in Canada to that in Chile?
Provide a succinct answer. 1.02. What is the difference between the highest and the second highest Gross enrolment ratio (%) in Pre-primary schools?
Ensure brevity in your answer.  13.79. What is the difference between the highest and the second highest Gross enrolment ratio (%) of Primary schools?
Make the answer very short. 2.22. What is the difference between the highest and the second highest Gross enrolment ratio (%) of Secondary schools?
Offer a very short reply. 4.19. What is the difference between the highest and the second highest Gross enrolment ratio (%) in Tertiary schools?
Offer a very short reply. 17.76. What is the difference between the highest and the lowest Gross enrolment ratio (%) in Pre-primary schools?
Your answer should be very brief. 85.31. What is the difference between the highest and the lowest Gross enrolment ratio (%) in Primary schools?
Give a very brief answer. 34.03. What is the difference between the highest and the lowest Gross enrolment ratio (%) of Secondary schools?
Provide a short and direct response. 71.61. What is the difference between the highest and the lowest Gross enrolment ratio (%) of Tertiary schools?
Keep it short and to the point. 32.31. 